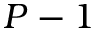Convert formula to latex. <formula><loc_0><loc_0><loc_500><loc_500>P - 1</formula> 